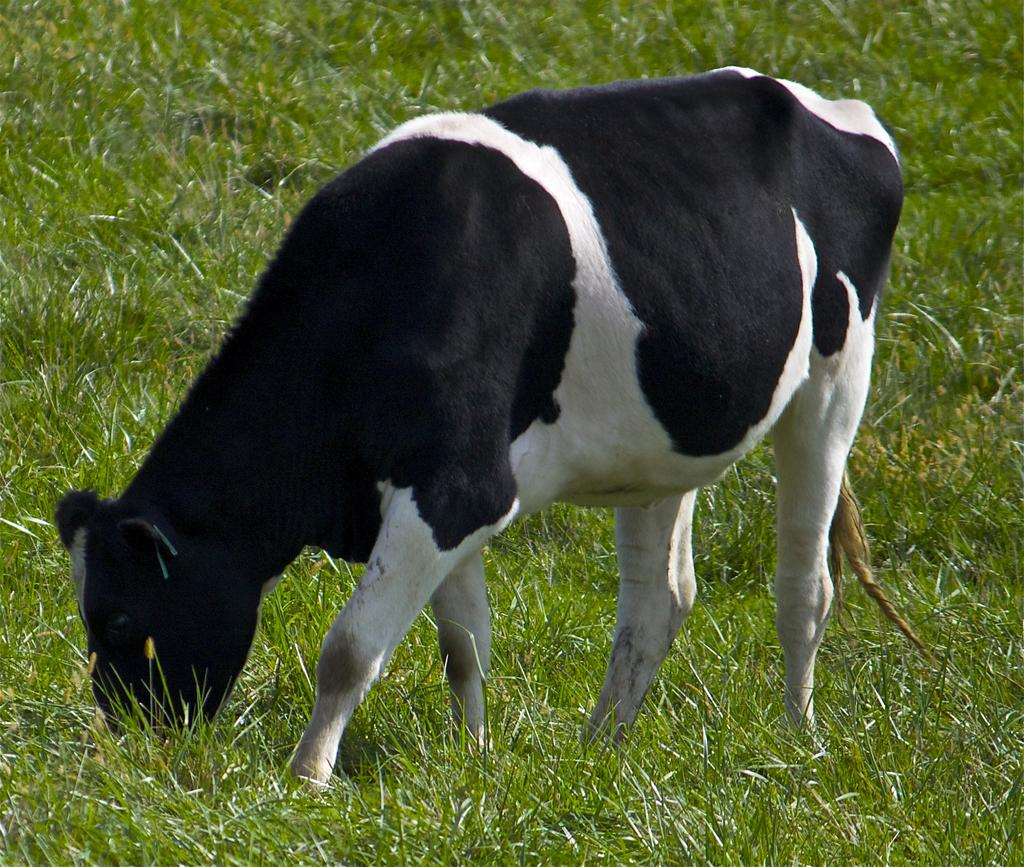What type of living creature is present in the image? There is an animal in the image. What can be seen in the background of the image? There is grass visible in the background of the image. What type of clouds can be seen in the image? There are no clouds visible in the image; it only features an animal and grass in the background. 